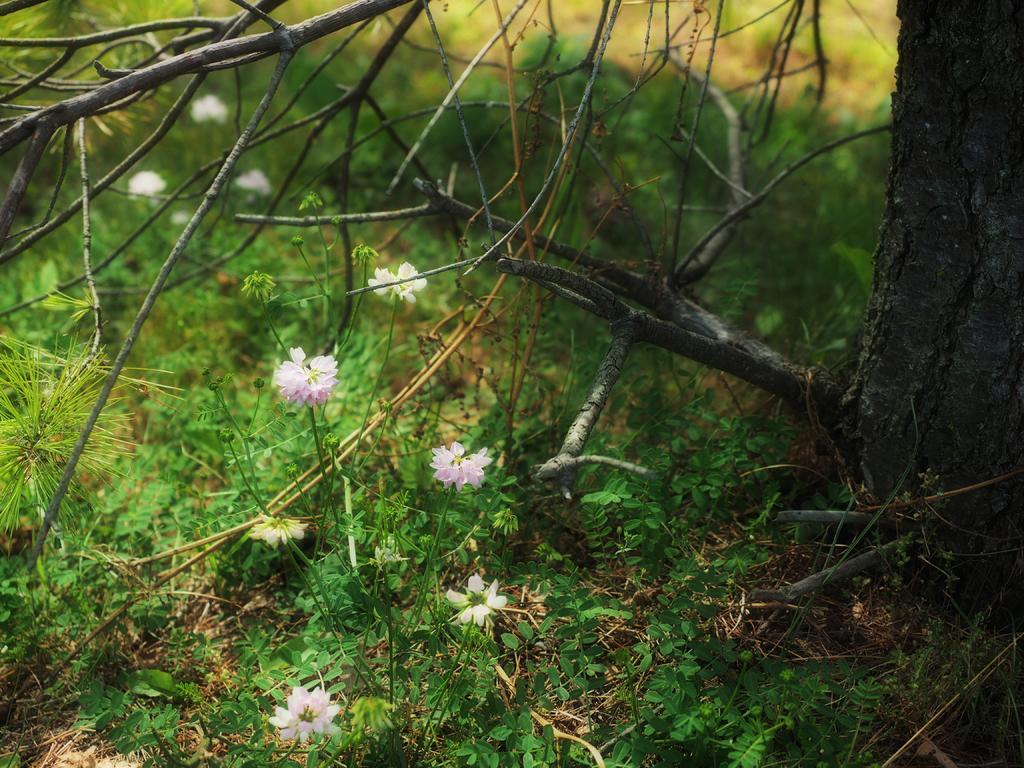Please provide a concise description of this image. In the image there is a tree trunk, some dry branches and there is a grass and in between the grass there are small flowers. 